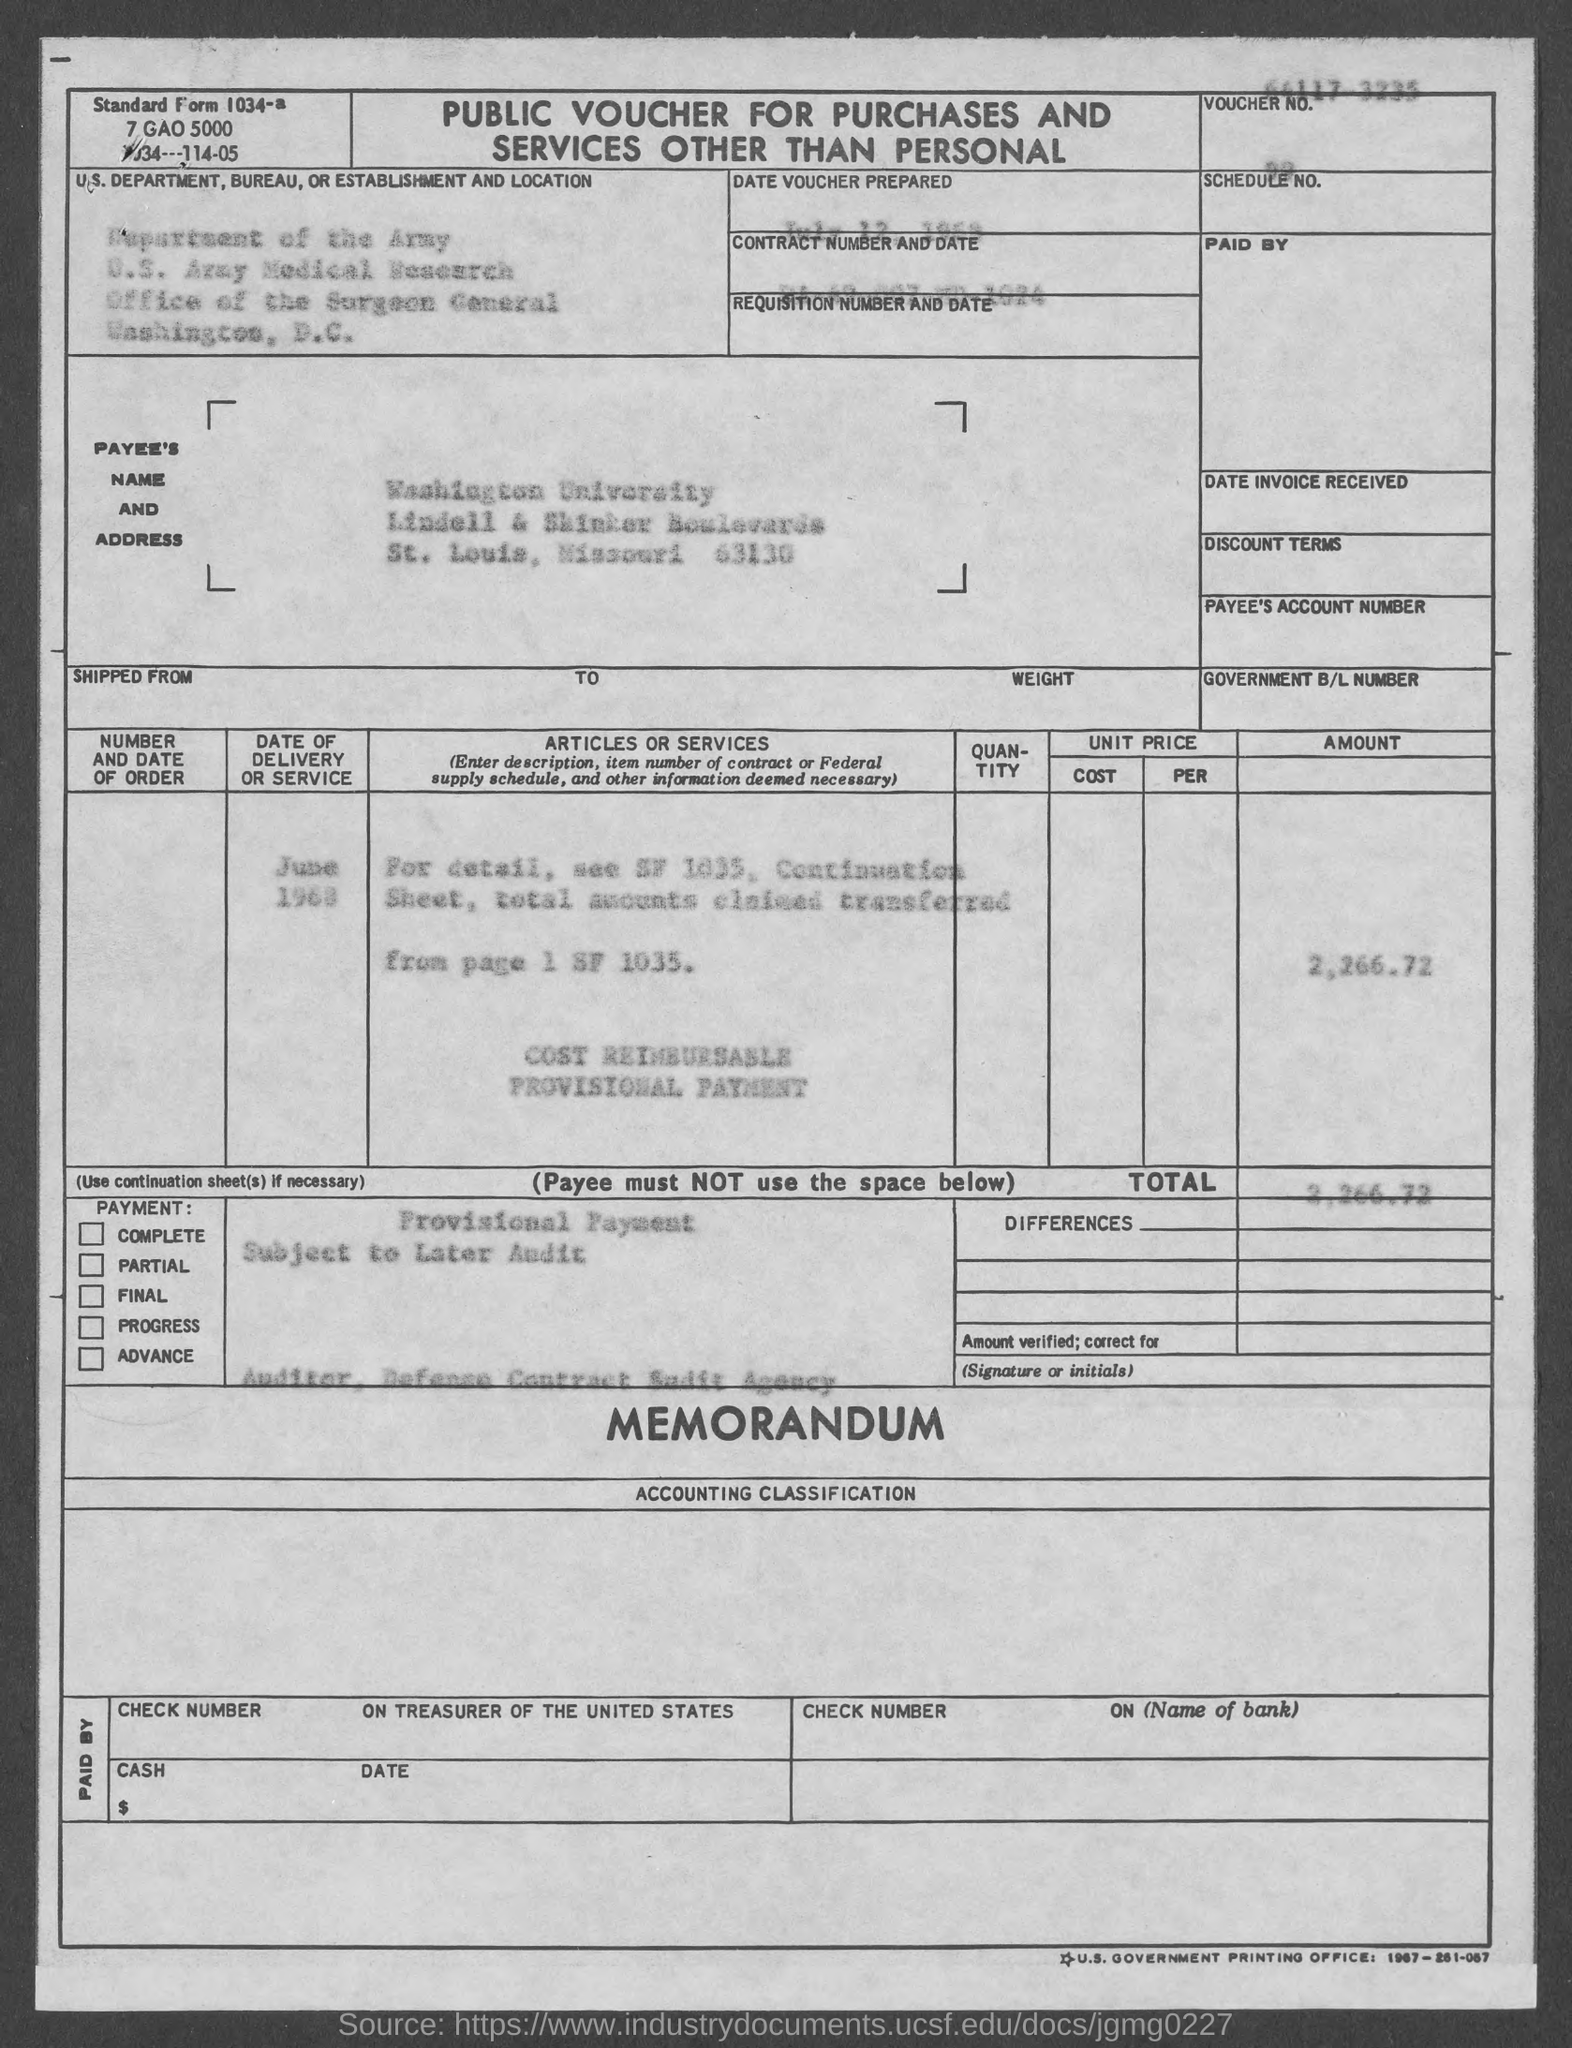What is the Standard Form No. given in the voucher?
Offer a very short reply. 1034a. What is the payee's name given in the voucher?
Ensure brevity in your answer.  Washington university. What is the Contract No. given in the voucher?
Your answer should be very brief. DA-49-007-MD-1024. What is the total amount mentioned in the voucher?
Your answer should be compact. 2,266.72. What type of voucher is given here?
Give a very brief answer. PUBLIC VOUCHER. 